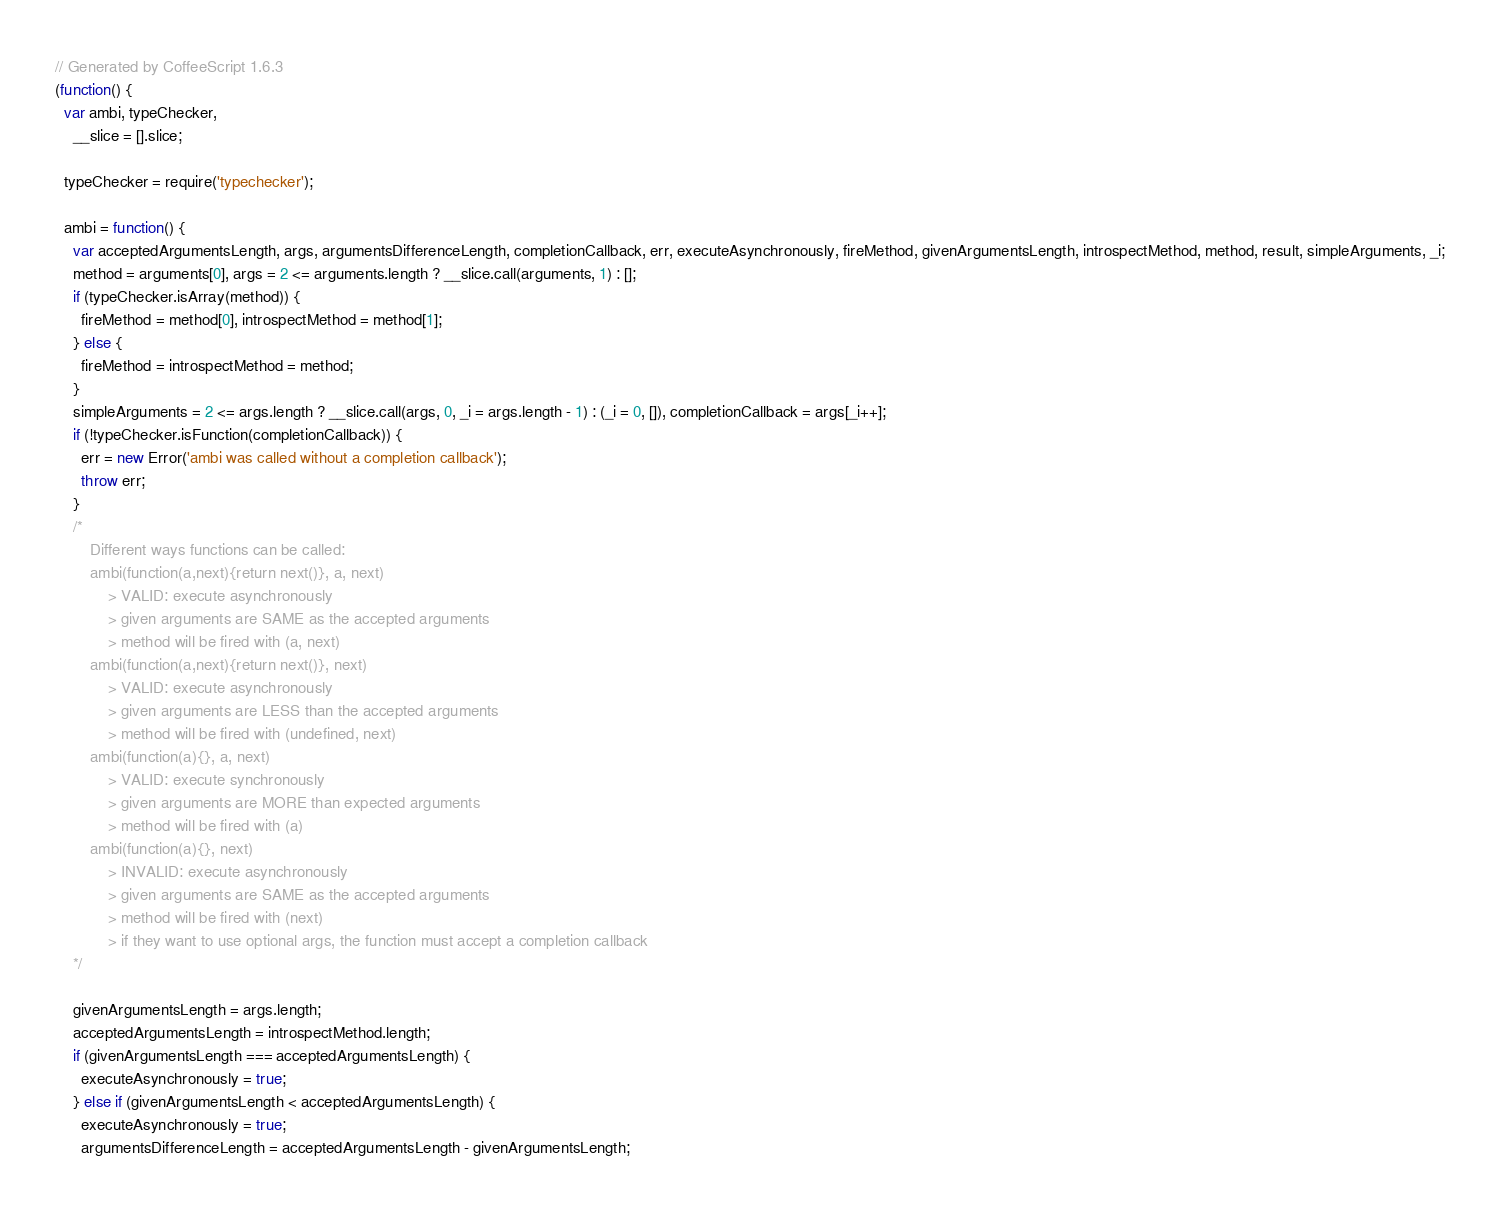<code> <loc_0><loc_0><loc_500><loc_500><_JavaScript_>// Generated by CoffeeScript 1.6.3
(function() {
  var ambi, typeChecker,
    __slice = [].slice;

  typeChecker = require('typechecker');

  ambi = function() {
    var acceptedArgumentsLength, args, argumentsDifferenceLength, completionCallback, err, executeAsynchronously, fireMethod, givenArgumentsLength, introspectMethod, method, result, simpleArguments, _i;
    method = arguments[0], args = 2 <= arguments.length ? __slice.call(arguments, 1) : [];
    if (typeChecker.isArray(method)) {
      fireMethod = method[0], introspectMethod = method[1];
    } else {
      fireMethod = introspectMethod = method;
    }
    simpleArguments = 2 <= args.length ? __slice.call(args, 0, _i = args.length - 1) : (_i = 0, []), completionCallback = args[_i++];
    if (!typeChecker.isFunction(completionCallback)) {
      err = new Error('ambi was called without a completion callback');
      throw err;
    }
    /*
    	Different ways functions can be called:
    	ambi(function(a,next){return next()}, a, next)
    		> VALID: execute asynchronously
    		> given arguments are SAME as the accepted arguments
    		> method will be fired with (a, next)
    	ambi(function(a,next){return next()}, next)
    		> VALID: execute asynchronously
    		> given arguments are LESS than the accepted arguments
    		> method will be fired with (undefined, next)
    	ambi(function(a){}, a, next)
    		> VALID: execute synchronously
    		> given arguments are MORE than expected arguments
    		> method will be fired with (a)
    	ambi(function(a){}, next)
    		> INVALID: execute asynchronously
    		> given arguments are SAME as the accepted arguments
    		> method will be fired with (next)
    		> if they want to use optional args, the function must accept a completion callback
    */

    givenArgumentsLength = args.length;
    acceptedArgumentsLength = introspectMethod.length;
    if (givenArgumentsLength === acceptedArgumentsLength) {
      executeAsynchronously = true;
    } else if (givenArgumentsLength < acceptedArgumentsLength) {
      executeAsynchronously = true;
      argumentsDifferenceLength = acceptedArgumentsLength - givenArgumentsLength;</code> 